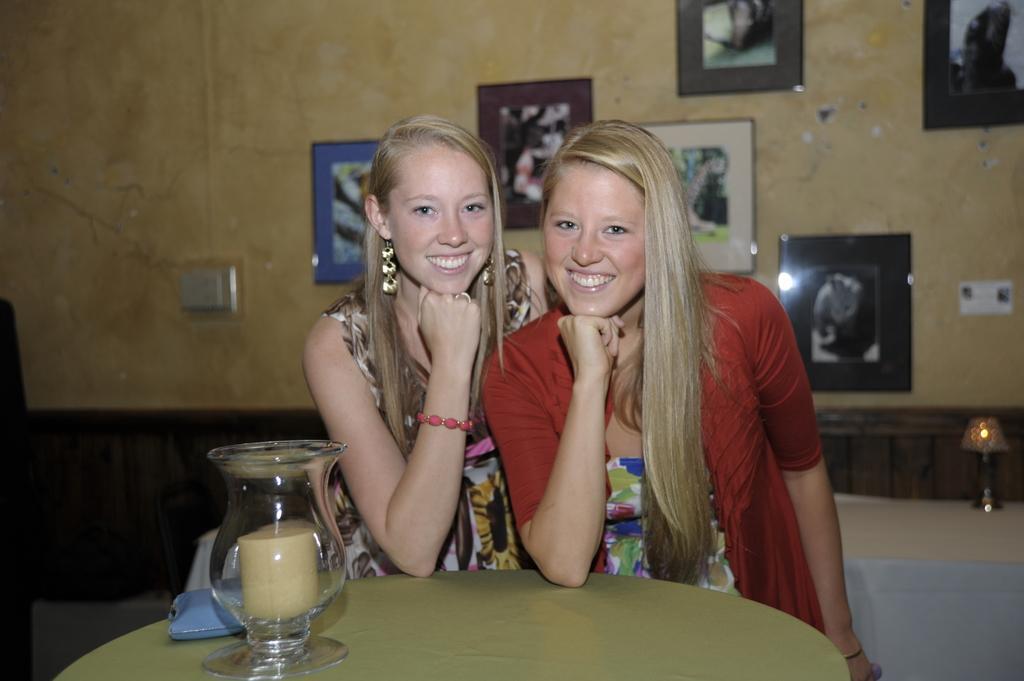Describe this image in one or two sentences. This picture shows two woman standing with a smile on their faces and we see a candle on the table and we see few photo frames on the wall. 